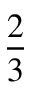<formula> <loc_0><loc_0><loc_500><loc_500>\frac { 2 } { 3 }</formula> 